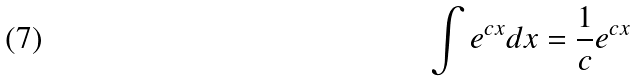<formula> <loc_0><loc_0><loc_500><loc_500>\int e ^ { c x } d x = \frac { 1 } { c } e ^ { c x }</formula> 